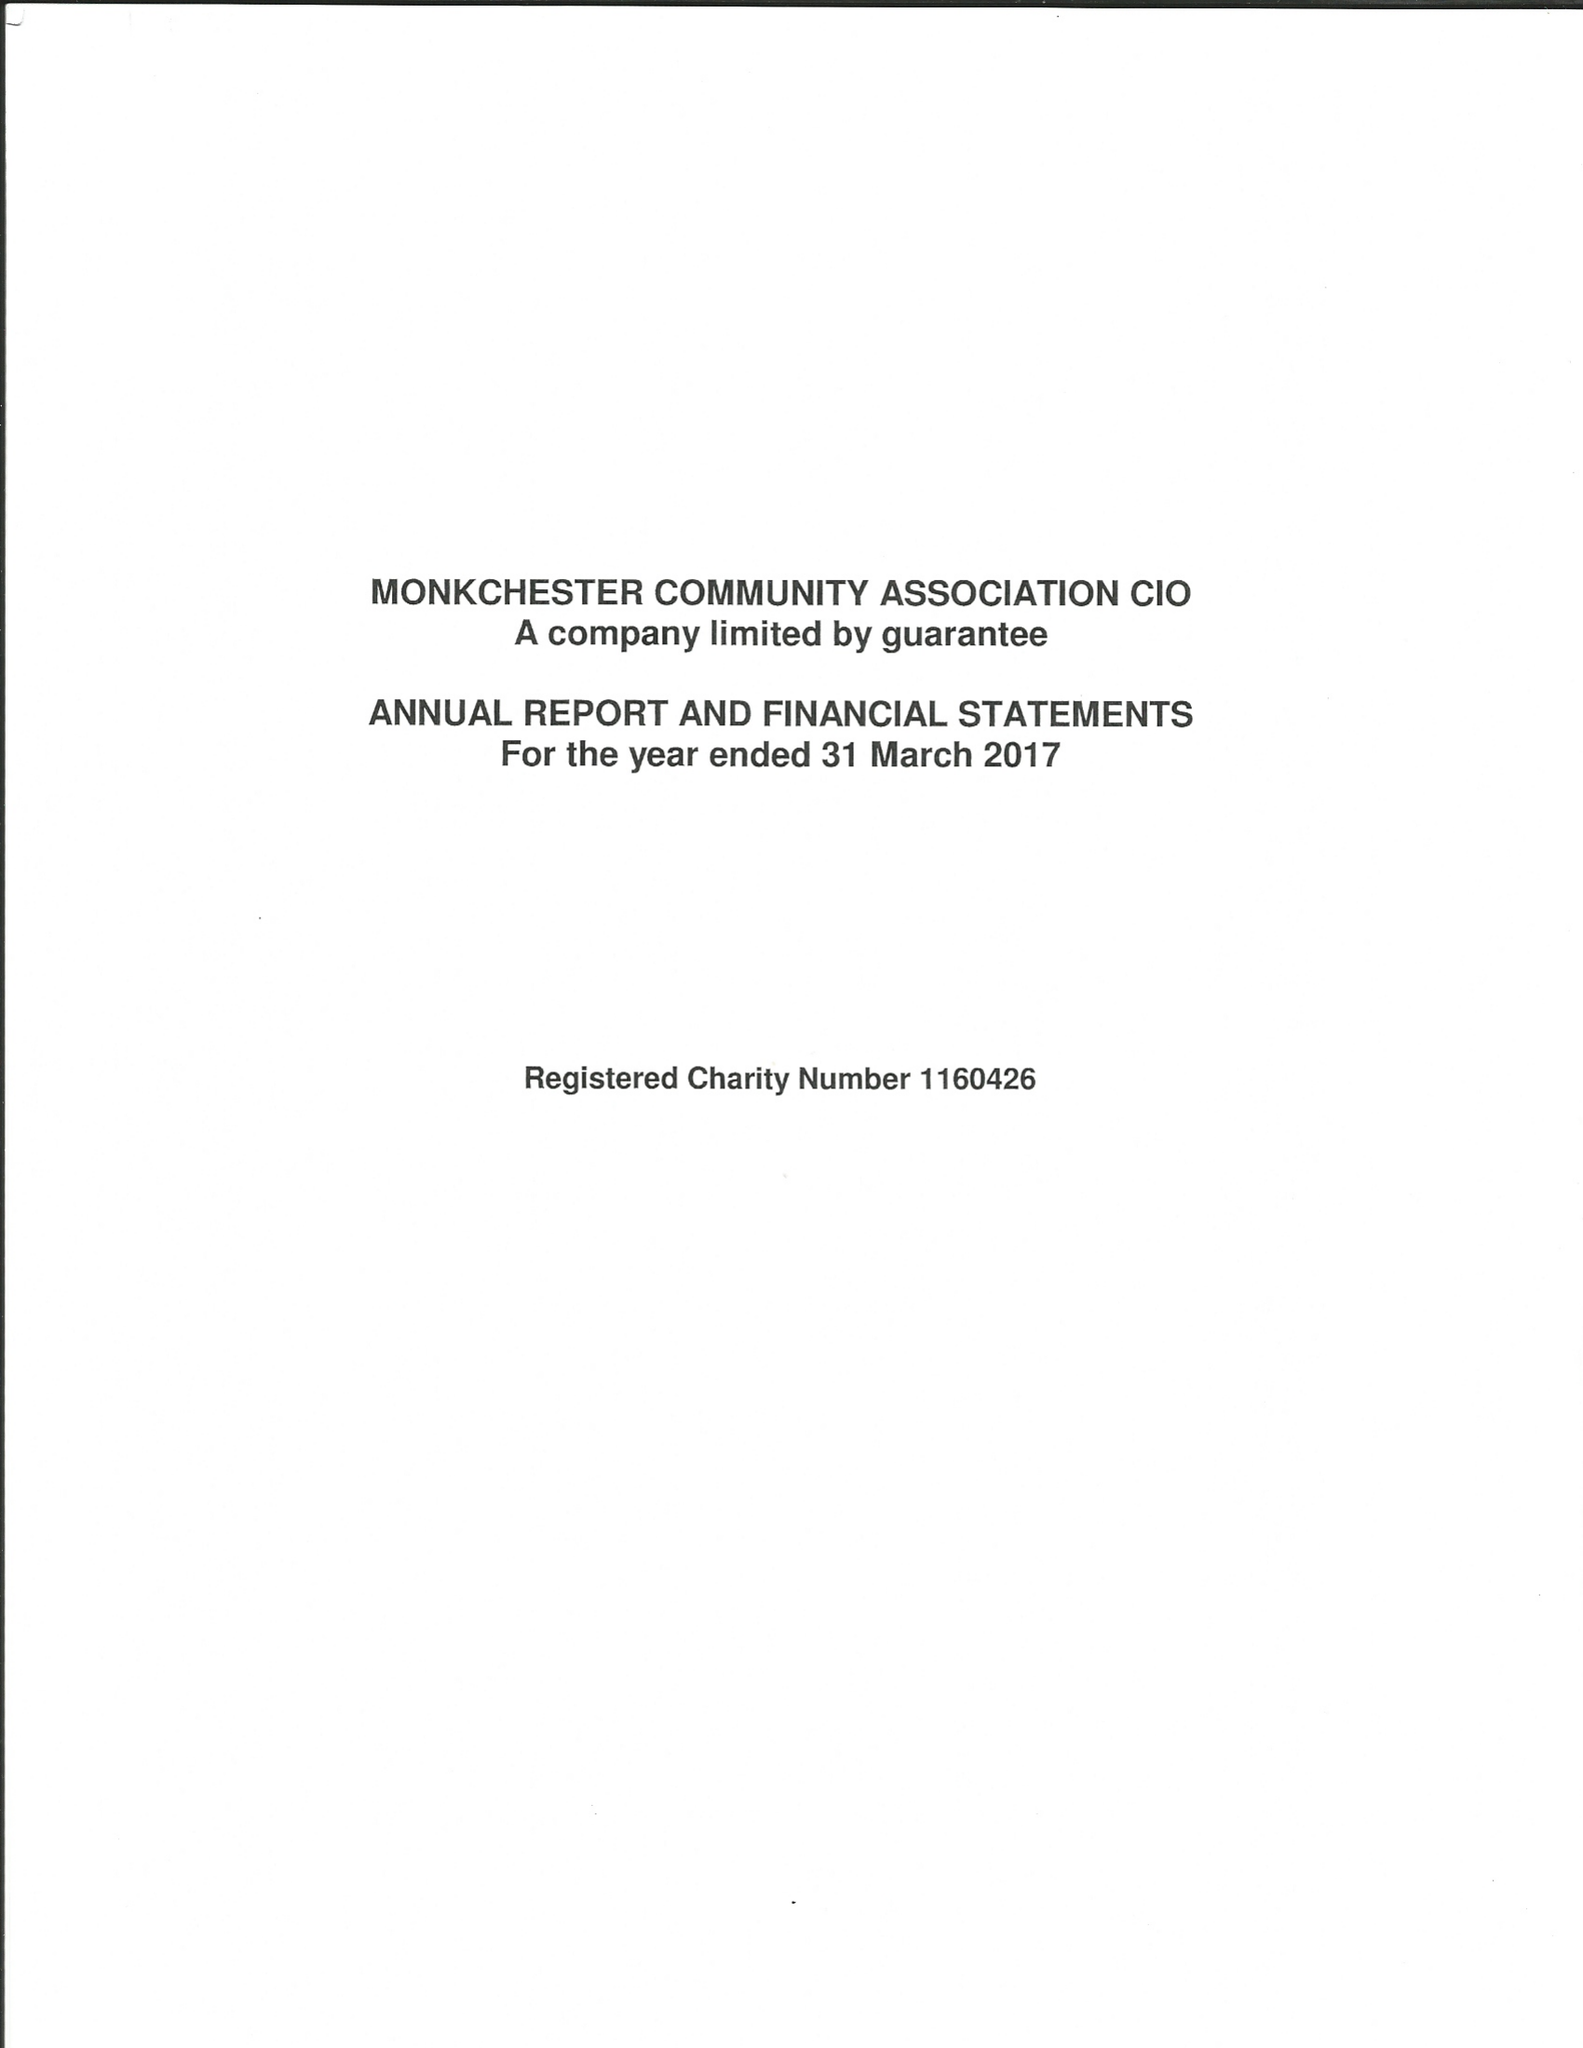What is the value for the address__postcode?
Answer the question using a single word or phrase. NE6 2LJ 